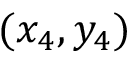<formula> <loc_0><loc_0><loc_500><loc_500>( x _ { 4 } , y _ { 4 } )</formula> 